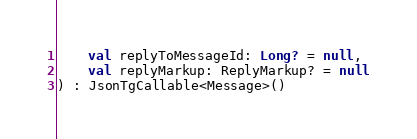<code> <loc_0><loc_0><loc_500><loc_500><_Kotlin_>    val replyToMessageId: Long? = null,
    val replyMarkup: ReplyMarkup? = null
) : JsonTgCallable<Message>()
</code> 